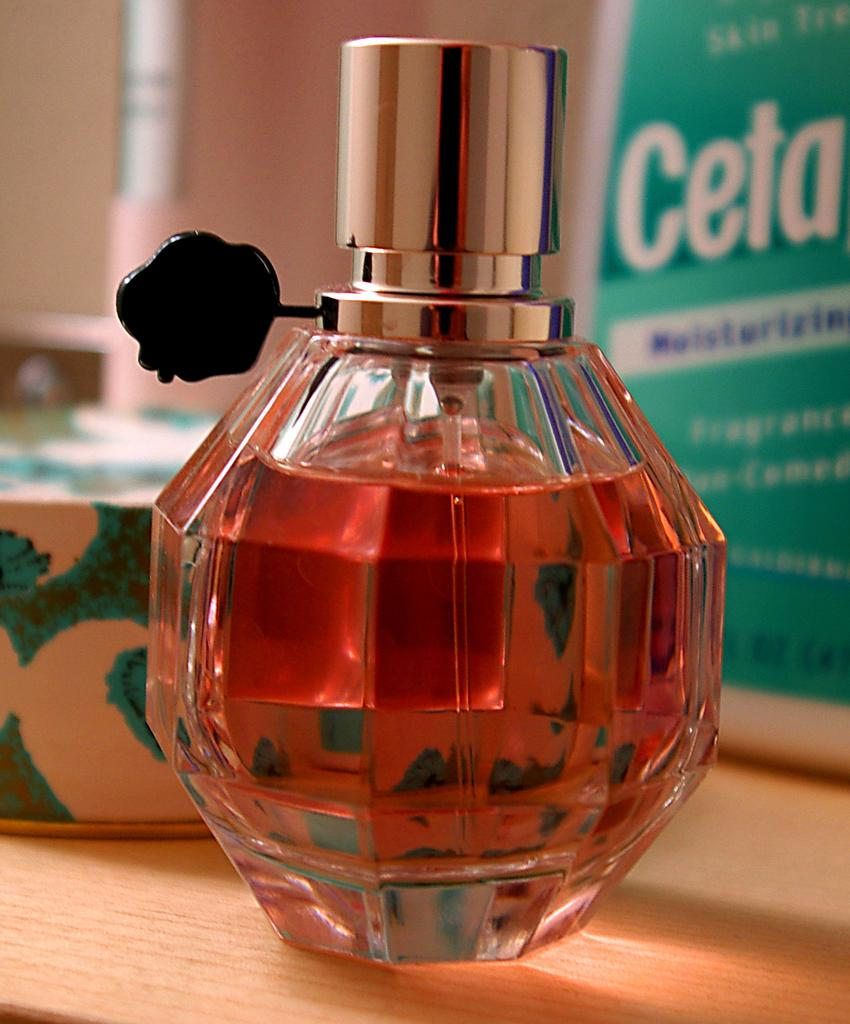<image>
Render a clear and concise summary of the photo. Brown bottle of perfume in front of a box that says "CETA". 